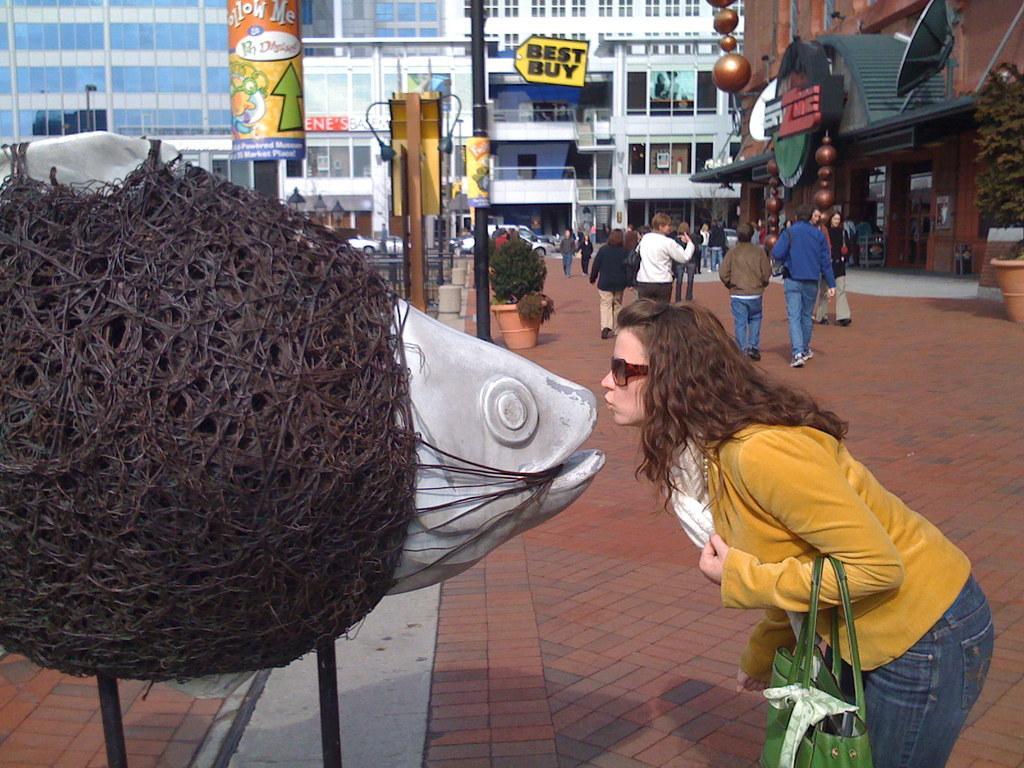Describe this image in one or two sentences. In the foreground of this image, on the left, there is a model of a fish on which there are threads. On the right, there is a woman standing and carrying a bag on the pavement. In the background, there are people walking, plants, boards, poles and the buildings. 